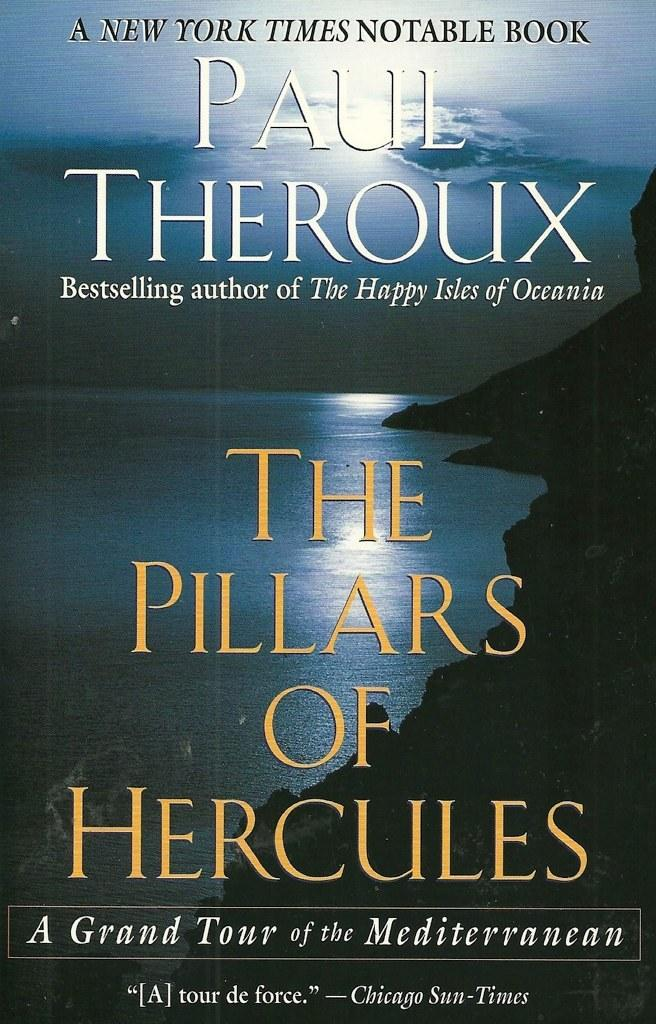<image>
Create a compact narrative representing the image presented. a book that is by paul theroux called the pillars of hercules 